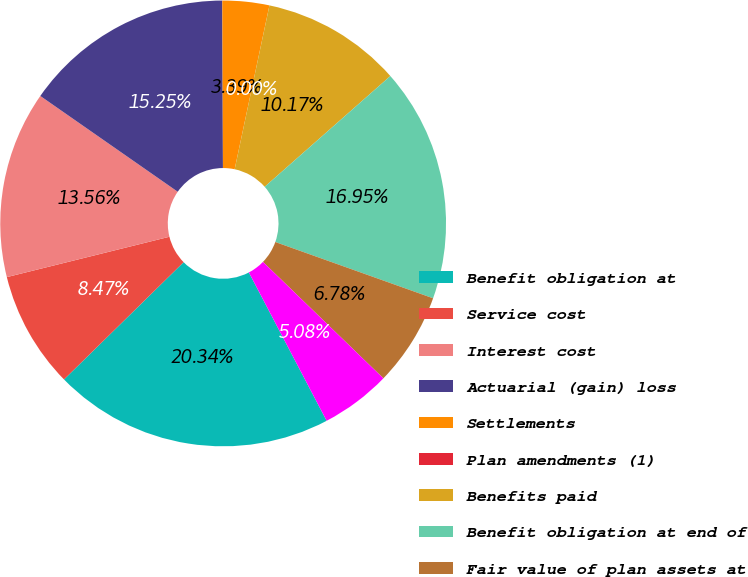Convert chart to OTSL. <chart><loc_0><loc_0><loc_500><loc_500><pie_chart><fcel>Benefit obligation at<fcel>Service cost<fcel>Interest cost<fcel>Actuarial (gain) loss<fcel>Settlements<fcel>Plan amendments (1)<fcel>Benefits paid<fcel>Benefit obligation at end of<fcel>Fair value of plan assets at<fcel>Actual return on plan assets<nl><fcel>20.34%<fcel>8.47%<fcel>13.56%<fcel>15.25%<fcel>3.39%<fcel>0.0%<fcel>10.17%<fcel>16.95%<fcel>6.78%<fcel>5.08%<nl></chart> 